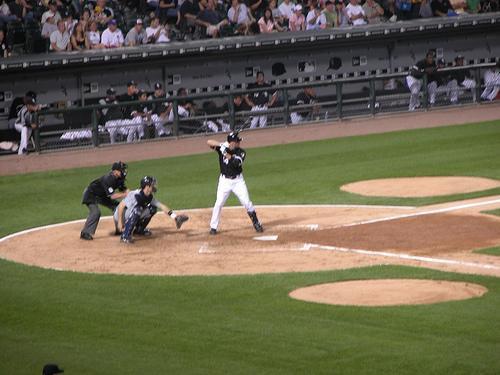How many people are there?
Give a very brief answer. 4. 